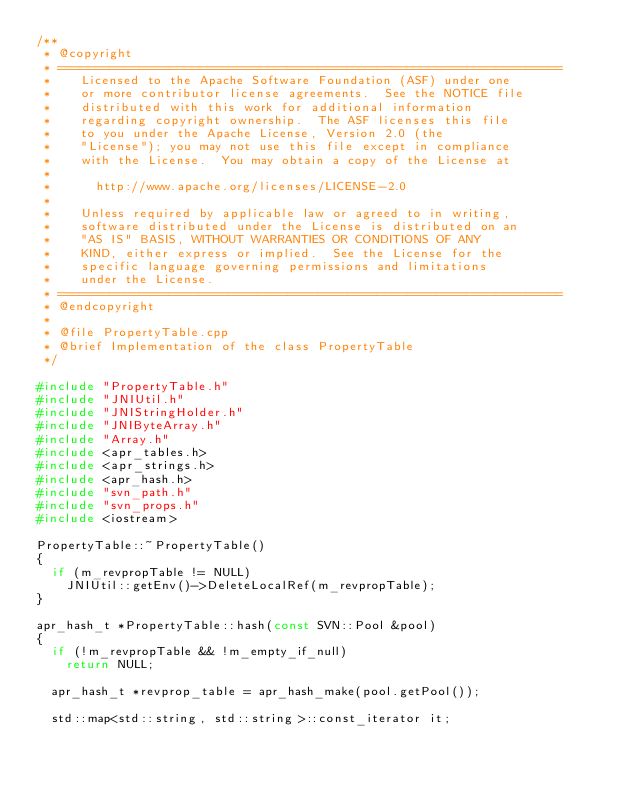Convert code to text. <code><loc_0><loc_0><loc_500><loc_500><_C++_>/**
 * @copyright
 * ====================================================================
 *    Licensed to the Apache Software Foundation (ASF) under one
 *    or more contributor license agreements.  See the NOTICE file
 *    distributed with this work for additional information
 *    regarding copyright ownership.  The ASF licenses this file
 *    to you under the Apache License, Version 2.0 (the
 *    "License"); you may not use this file except in compliance
 *    with the License.  You may obtain a copy of the License at
 *
 *      http://www.apache.org/licenses/LICENSE-2.0
 *
 *    Unless required by applicable law or agreed to in writing,
 *    software distributed under the License is distributed on an
 *    "AS IS" BASIS, WITHOUT WARRANTIES OR CONDITIONS OF ANY
 *    KIND, either express or implied.  See the License for the
 *    specific language governing permissions and limitations
 *    under the License.
 * ====================================================================
 * @endcopyright
 *
 * @file PropertyTable.cpp
 * @brief Implementation of the class PropertyTable
 */

#include "PropertyTable.h"
#include "JNIUtil.h"
#include "JNIStringHolder.h"
#include "JNIByteArray.h"
#include "Array.h"
#include <apr_tables.h>
#include <apr_strings.h>
#include <apr_hash.h>
#include "svn_path.h"
#include "svn_props.h"
#include <iostream>

PropertyTable::~PropertyTable()
{
  if (m_revpropTable != NULL)
    JNIUtil::getEnv()->DeleteLocalRef(m_revpropTable);
}

apr_hash_t *PropertyTable::hash(const SVN::Pool &pool)
{
  if (!m_revpropTable && !m_empty_if_null)
    return NULL;

  apr_hash_t *revprop_table = apr_hash_make(pool.getPool());

  std::map<std::string, std::string>::const_iterator it;</code> 